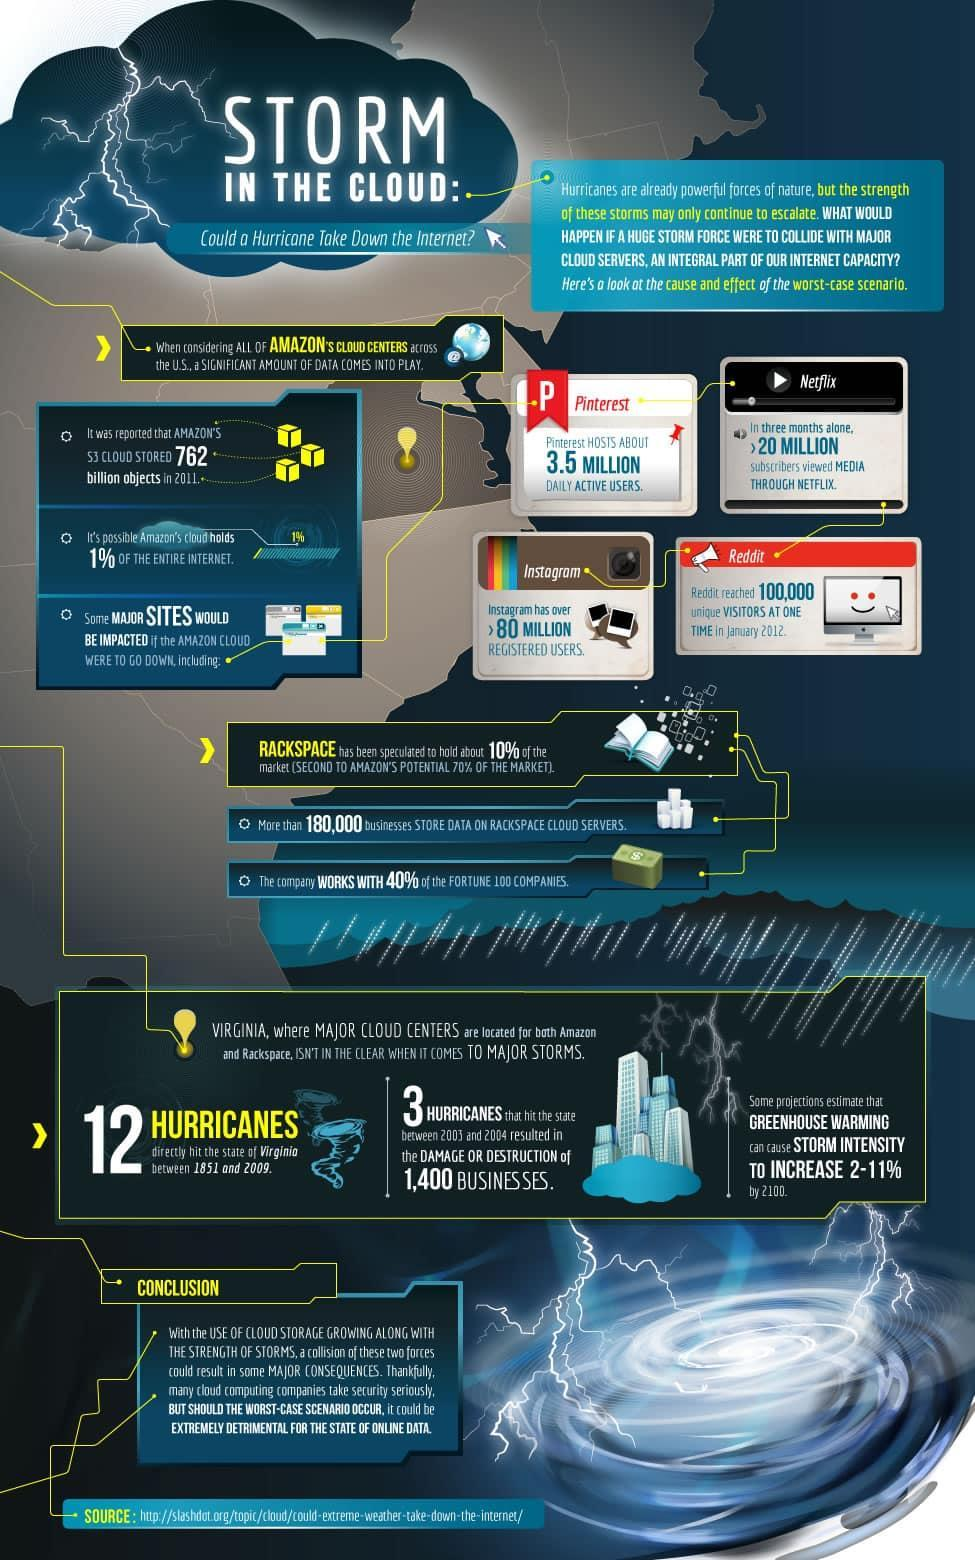how many registered users in Instagram
Answer the question with a short phrase. > 80 million How many hurricanes between 2004 and2004 3 In a span of 1.5 centuries, how many hurricanes have hit Virginia 12 How many active daily users in Pinterest 3.5 million how many subscribers viewed Media through Netflix in a quarter of the year > 20 Million 